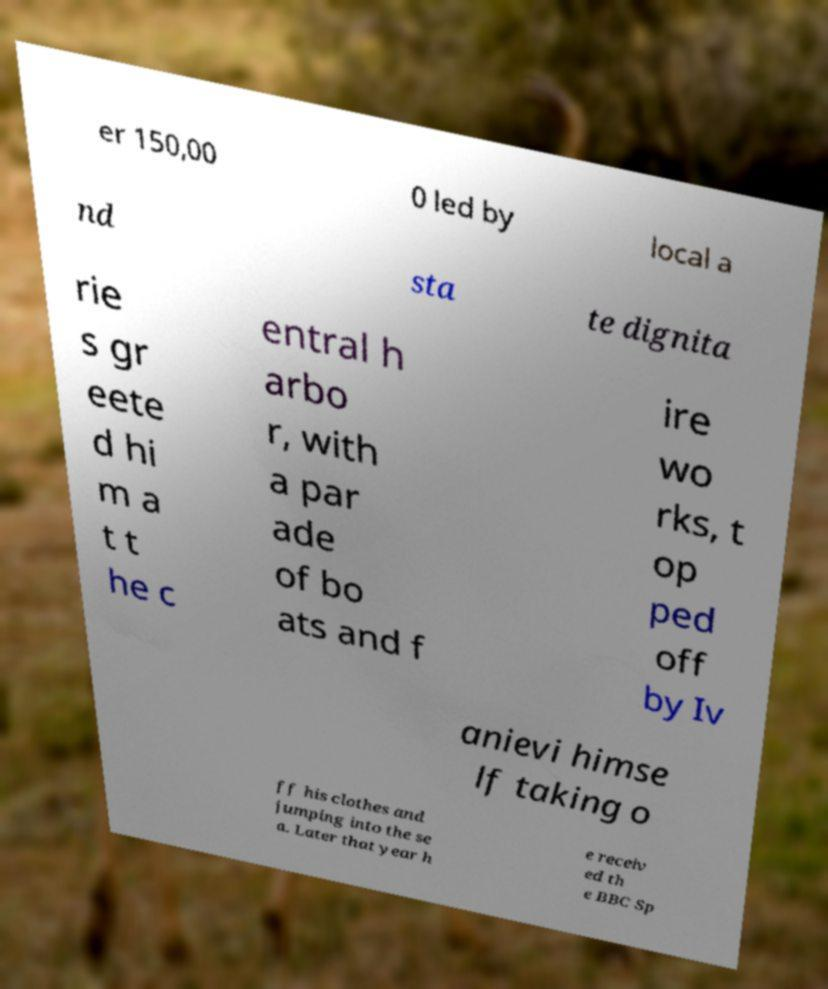Can you accurately transcribe the text from the provided image for me? er 150,00 0 led by local a nd sta te dignita rie s gr eete d hi m a t t he c entral h arbo r, with a par ade of bo ats and f ire wo rks, t op ped off by Iv anievi himse lf taking o ff his clothes and jumping into the se a. Later that year h e receiv ed th e BBC Sp 